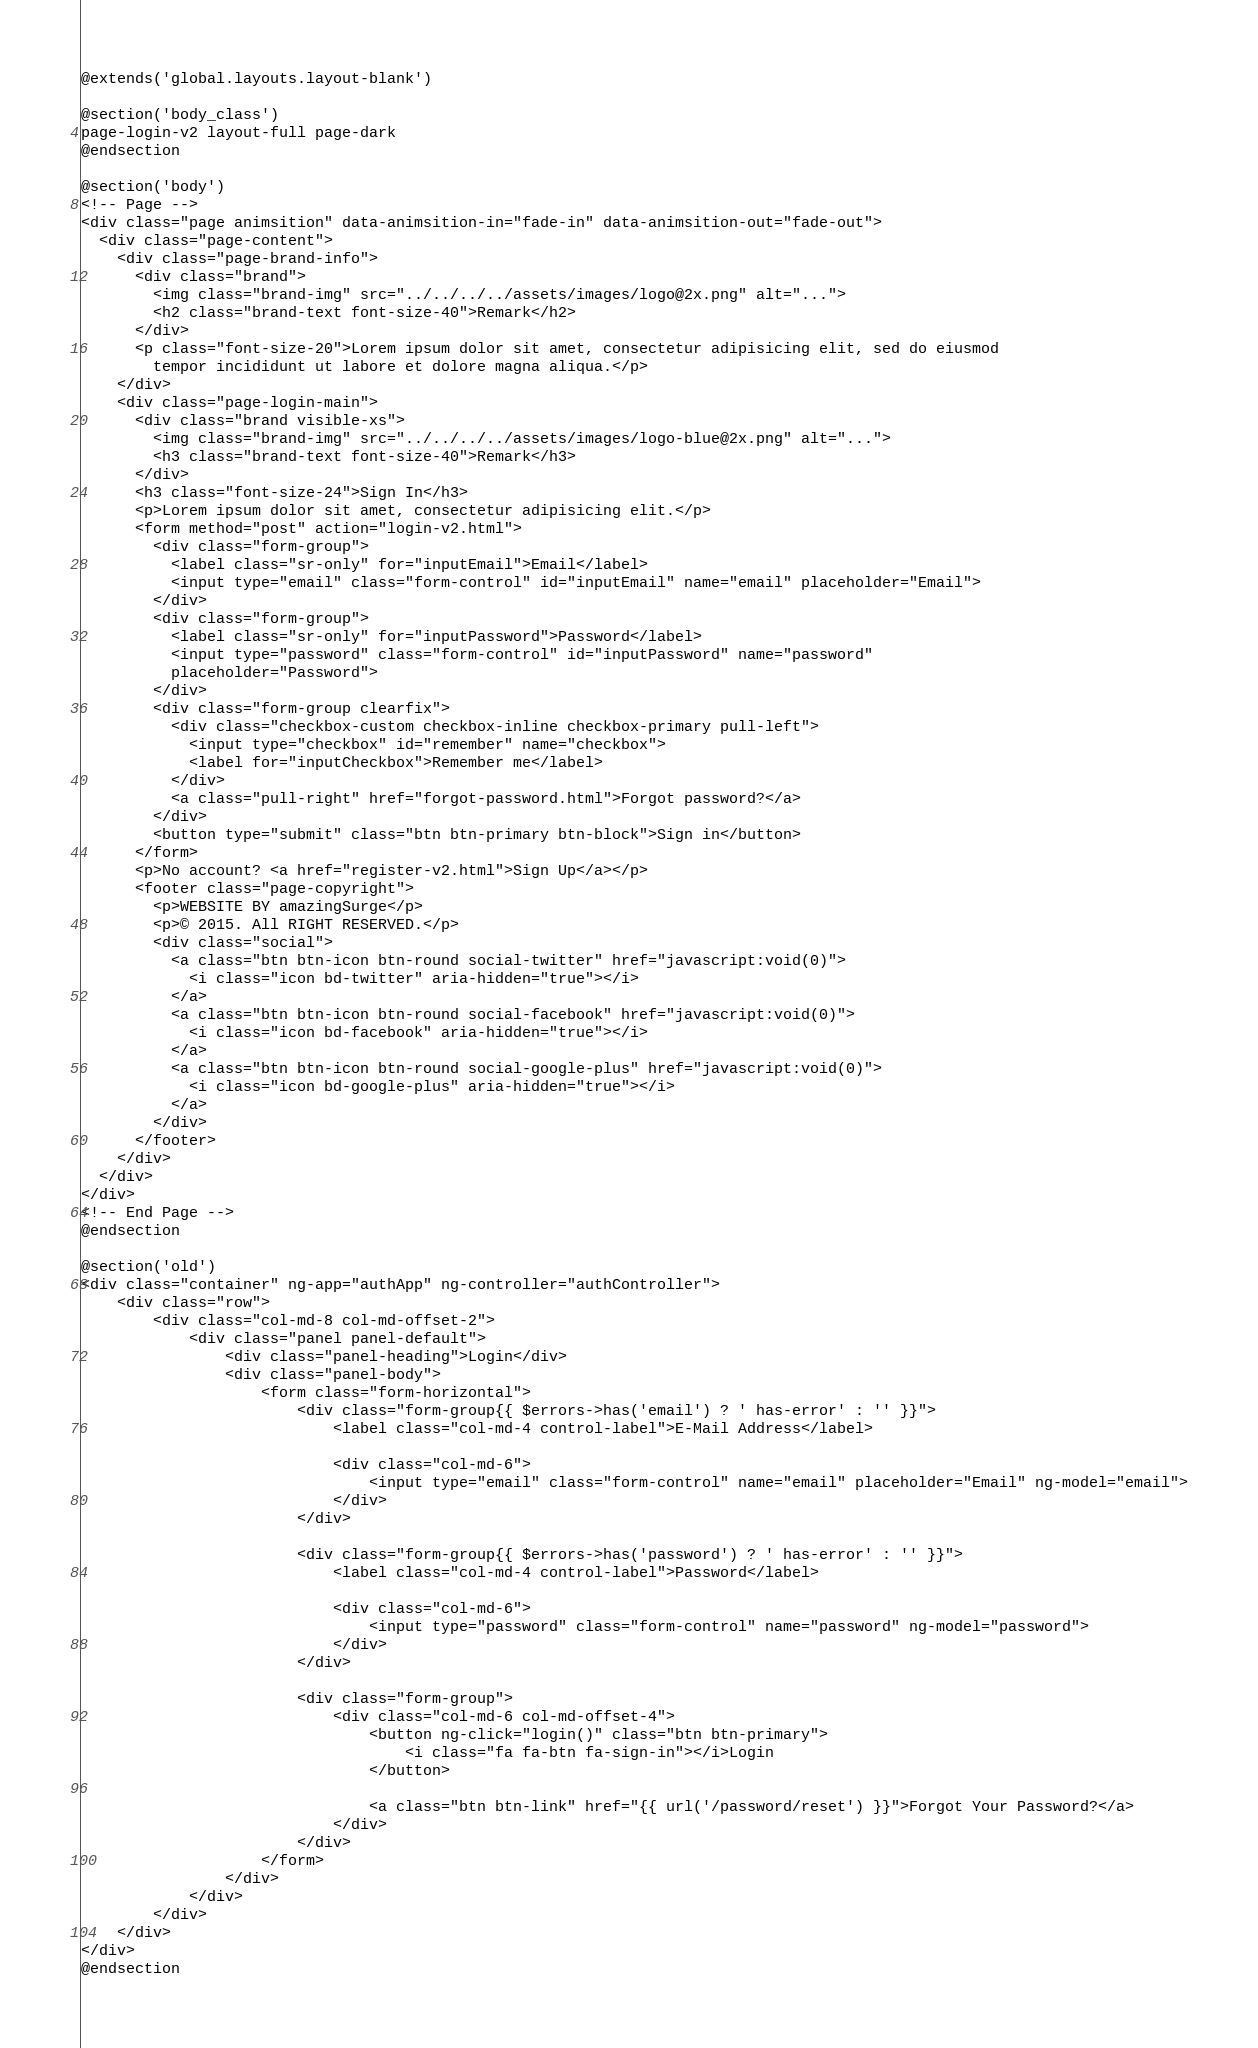Convert code to text. <code><loc_0><loc_0><loc_500><loc_500><_PHP_>@extends('global.layouts.layout-blank')

@section('body_class')
page-login-v2 layout-full page-dark
@endsection

@section('body')
<!-- Page -->
<div class="page animsition" data-animsition-in="fade-in" data-animsition-out="fade-out">
  <div class="page-content">
    <div class="page-brand-info">
      <div class="brand">
        <img class="brand-img" src="../../../../assets/images/logo@2x.png" alt="...">
        <h2 class="brand-text font-size-40">Remark</h2>
      </div>
      <p class="font-size-20">Lorem ipsum dolor sit amet, consectetur adipisicing elit, sed do eiusmod
        tempor incididunt ut labore et dolore magna aliqua.</p>
    </div>
    <div class="page-login-main">
      <div class="brand visible-xs">
        <img class="brand-img" src="../../../../assets/images/logo-blue@2x.png" alt="...">
        <h3 class="brand-text font-size-40">Remark</h3>
      </div>
      <h3 class="font-size-24">Sign In</h3>
      <p>Lorem ipsum dolor sit amet, consectetur adipisicing elit.</p>
      <form method="post" action="login-v2.html">
        <div class="form-group">
          <label class="sr-only" for="inputEmail">Email</label>
          <input type="email" class="form-control" id="inputEmail" name="email" placeholder="Email">
        </div>
        <div class="form-group">
          <label class="sr-only" for="inputPassword">Password</label>
          <input type="password" class="form-control" id="inputPassword" name="password"
          placeholder="Password">
        </div>
        <div class="form-group clearfix">
          <div class="checkbox-custom checkbox-inline checkbox-primary pull-left">
            <input type="checkbox" id="remember" name="checkbox">
            <label for="inputCheckbox">Remember me</label>
          </div>
          <a class="pull-right" href="forgot-password.html">Forgot password?</a>
        </div>
        <button type="submit" class="btn btn-primary btn-block">Sign in</button>
      </form>
      <p>No account? <a href="register-v2.html">Sign Up</a></p>
      <footer class="page-copyright">
        <p>WEBSITE BY amazingSurge</p>
        <p>© 2015. All RIGHT RESERVED.</p>
        <div class="social">
          <a class="btn btn-icon btn-round social-twitter" href="javascript:void(0)">
            <i class="icon bd-twitter" aria-hidden="true"></i>
          </a>
          <a class="btn btn-icon btn-round social-facebook" href="javascript:void(0)">
            <i class="icon bd-facebook" aria-hidden="true"></i>
          </a>
          <a class="btn btn-icon btn-round social-google-plus" href="javascript:void(0)">
            <i class="icon bd-google-plus" aria-hidden="true"></i>
          </a>
        </div>
      </footer>
    </div>
  </div>
</div>
<!-- End Page -->
@endsection

@section('old')
<div class="container" ng-app="authApp" ng-controller="authController">
    <div class="row">
        <div class="col-md-8 col-md-offset-2">
            <div class="panel panel-default">
                <div class="panel-heading">Login</div>
                <div class="panel-body">
                    <form class="form-horizontal">
                        <div class="form-group{{ $errors->has('email') ? ' has-error' : '' }}">
                            <label class="col-md-4 control-label">E-Mail Address</label>

                            <div class="col-md-6">
                                <input type="email" class="form-control" name="email" placeholder="Email" ng-model="email">
                            </div>
                        </div>

                        <div class="form-group{{ $errors->has('password') ? ' has-error' : '' }}">
                            <label class="col-md-4 control-label">Password</label>

                            <div class="col-md-6">
                                <input type="password" class="form-control" name="password" ng-model="password">
                            </div>
                        </div>

                        <div class="form-group">
                            <div class="col-md-6 col-md-offset-4">
                                <button ng-click="login()" class="btn btn-primary">
                                    <i class="fa fa-btn fa-sign-in"></i>Login
                                </button>

                                <a class="btn btn-link" href="{{ url('/password/reset') }}">Forgot Your Password?</a>
                            </div>
                        </div>
                    </form>
                </div>
            </div>
        </div>
    </div>
</div>
@endsection
</code> 